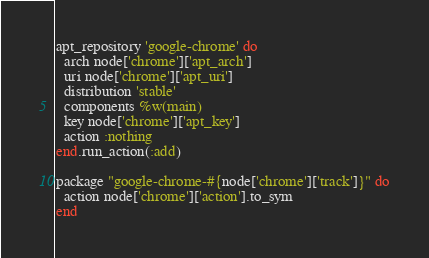Convert code to text. <code><loc_0><loc_0><loc_500><loc_500><_Ruby_>apt_repository 'google-chrome' do
  arch node['chrome']['apt_arch']
  uri node['chrome']['apt_uri']
  distribution 'stable'
  components %w(main)
  key node['chrome']['apt_key']
  action :nothing
end.run_action(:add)

package "google-chrome-#{node['chrome']['track']}" do
  action node['chrome']['action'].to_sym
end
</code> 